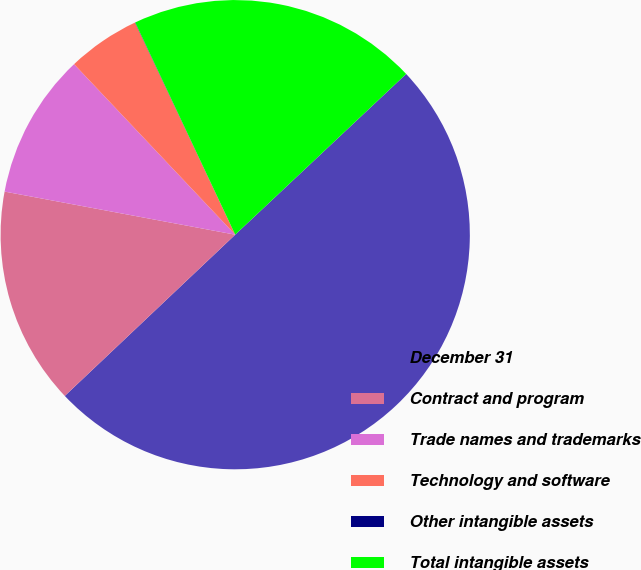Convert chart to OTSL. <chart><loc_0><loc_0><loc_500><loc_500><pie_chart><fcel>December 31<fcel>Contract and program<fcel>Trade names and trademarks<fcel>Technology and software<fcel>Other intangible assets<fcel>Total intangible assets<nl><fcel>49.95%<fcel>15.0%<fcel>10.01%<fcel>5.02%<fcel>0.02%<fcel>20.0%<nl></chart> 